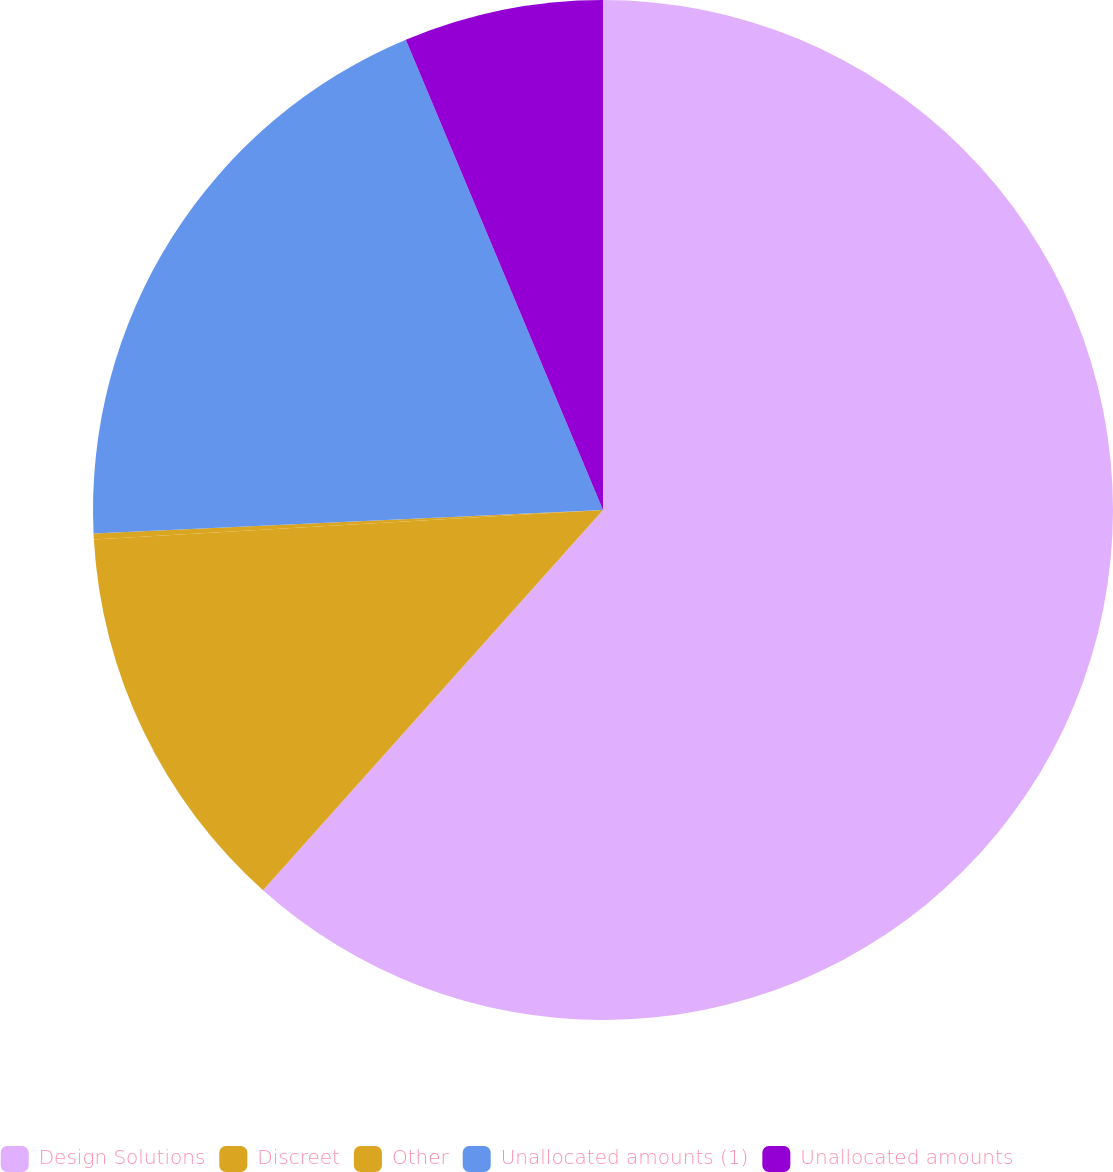Convert chart to OTSL. <chart><loc_0><loc_0><loc_500><loc_500><pie_chart><fcel>Design Solutions<fcel>Discreet<fcel>Other<fcel>Unallocated amounts (1)<fcel>Unallocated amounts<nl><fcel>61.62%<fcel>12.47%<fcel>0.18%<fcel>19.42%<fcel>6.32%<nl></chart> 